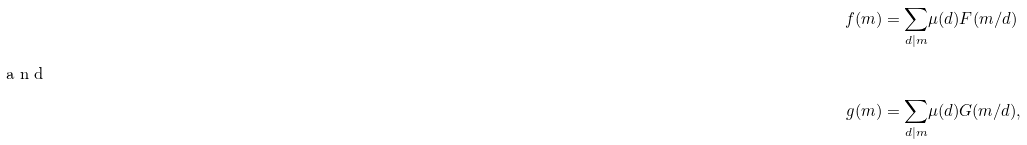<formula> <loc_0><loc_0><loc_500><loc_500>f ( m ) & = \underset { d | m } { \sum } \mu ( d ) F ( m / d ) \\ \intertext { a n d } g ( m ) & = \underset { d | m } { \sum } \mu ( d ) G ( m / d ) ,</formula> 